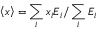<formula> <loc_0><loc_0><loc_500><loc_500>\left < x \right > = \sum _ { i } { x _ { i } E _ { i } } / \sum _ { i } { E _ { i } }</formula> 